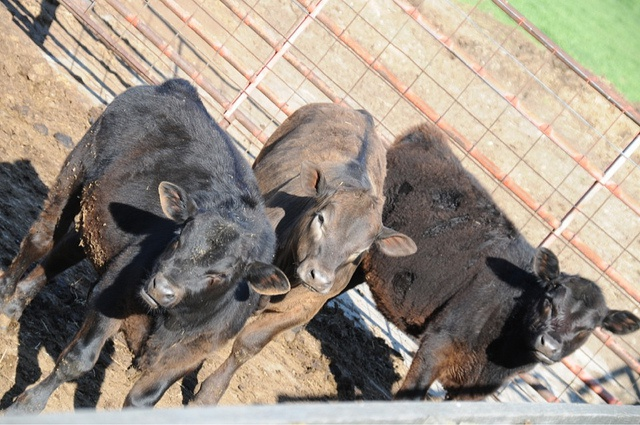Describe the objects in this image and their specific colors. I can see cow in gray and black tones, cow in gray, black, and darkgray tones, and cow in black, darkgray, tan, and gray tones in this image. 